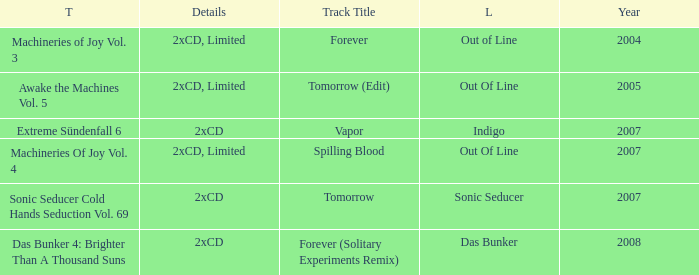Which label has a year older than 2004 and a 2xcd detail as well as the sonic seducer cold hands seduction vol. 69 title? Sonic Seducer. Parse the table in full. {'header': ['T', 'Details', 'Track Title', 'L', 'Year'], 'rows': [['Machineries of Joy Vol. 3', '2xCD, Limited', 'Forever', 'Out of Line', '2004'], ['Awake the Machines Vol. 5', '2xCD, Limited', 'Tomorrow (Edit)', 'Out Of Line', '2005'], ['Extreme Sündenfall 6', '2xCD', 'Vapor', 'Indigo', '2007'], ['Machineries Of Joy Vol. 4', '2xCD, Limited', 'Spilling Blood', 'Out Of Line', '2007'], ['Sonic Seducer Cold Hands Seduction Vol. 69', '2xCD', 'Tomorrow', 'Sonic Seducer', '2007'], ['Das Bunker 4: Brighter Than A Thousand Suns', '2xCD', 'Forever (Solitary Experiments Remix)', 'Das Bunker', '2008']]} 